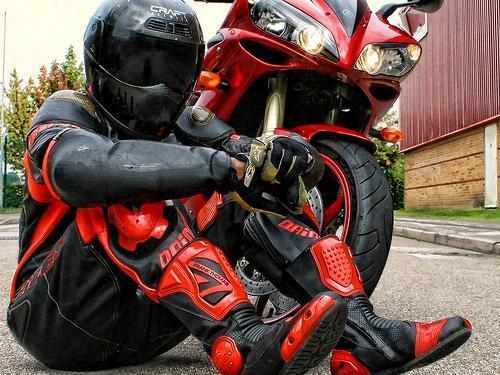How many motorcycles are visible?
Give a very brief answer. 1. How many people are pictured?
Give a very brief answer. 1. 